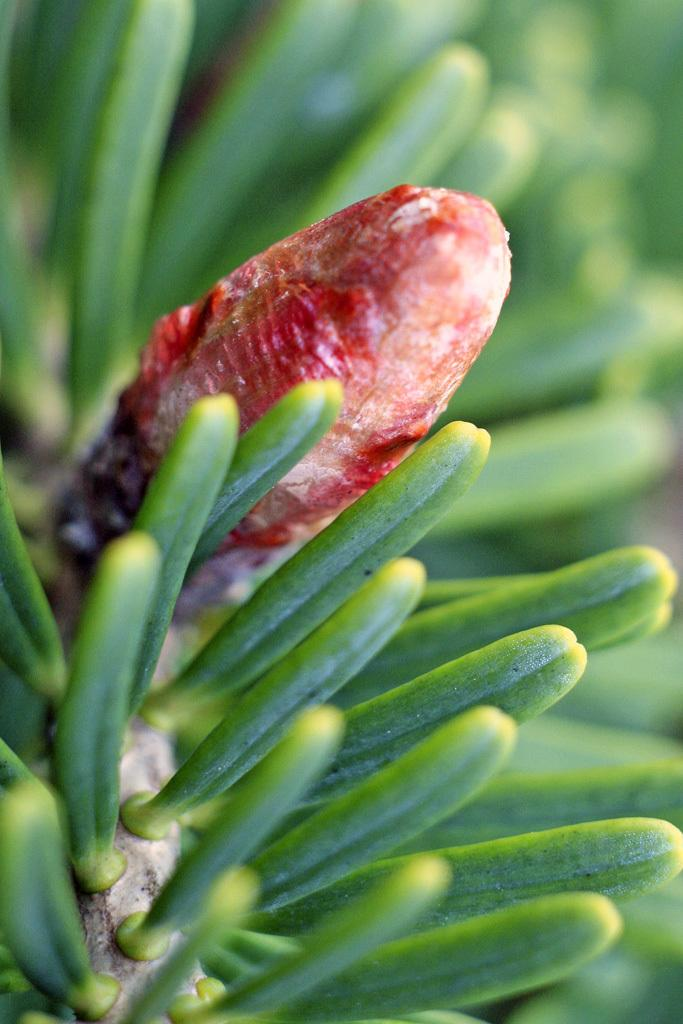What is present in the image? There is a branch in the image. What can be observed about the branch? The branch contains leaves and has buds on it. How many dogs are sitting on the box in the image? There is no box or dogs present in the image; it only features a branch with leaves and buds. 